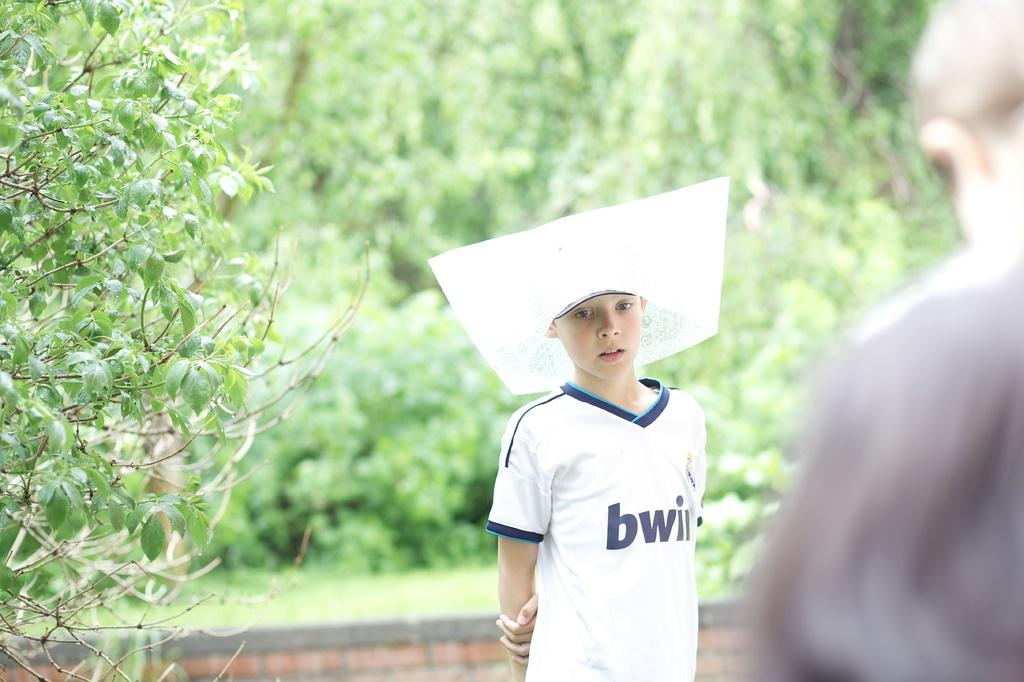<image>
Write a terse but informative summary of the picture. a boy in a white Tee shirt with a BWII logo in blue. 